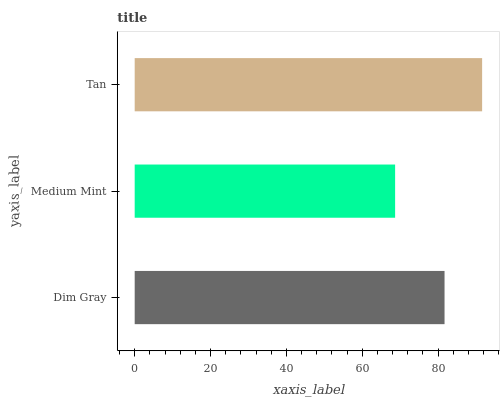Is Medium Mint the minimum?
Answer yes or no. Yes. Is Tan the maximum?
Answer yes or no. Yes. Is Tan the minimum?
Answer yes or no. No. Is Medium Mint the maximum?
Answer yes or no. No. Is Tan greater than Medium Mint?
Answer yes or no. Yes. Is Medium Mint less than Tan?
Answer yes or no. Yes. Is Medium Mint greater than Tan?
Answer yes or no. No. Is Tan less than Medium Mint?
Answer yes or no. No. Is Dim Gray the high median?
Answer yes or no. Yes. Is Dim Gray the low median?
Answer yes or no. Yes. Is Tan the high median?
Answer yes or no. No. Is Tan the low median?
Answer yes or no. No. 